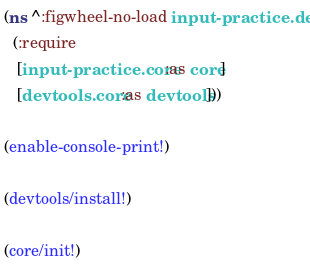<code> <loc_0><loc_0><loc_500><loc_500><_Clojure_>(ns ^:figwheel-no-load input-practice.dev
  (:require
   [input-practice.core :as core]
   [devtools.core :as devtools]))

(enable-console-print!)

(devtools/install!)

(core/init!)
</code> 